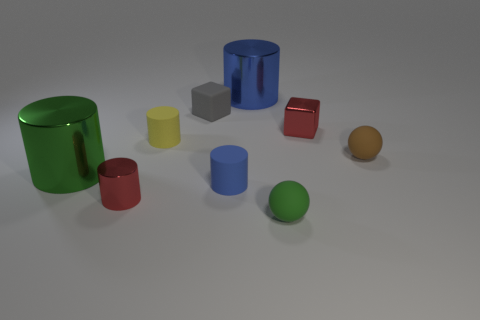Subtract all tiny red metallic cylinders. How many cylinders are left? 4 Subtract all brown balls. How many blue cylinders are left? 2 Subtract all yellow cylinders. How many cylinders are left? 4 Subtract all blocks. How many objects are left? 7 Subtract all blue cylinders. Subtract all gray blocks. How many cylinders are left? 3 Add 1 shiny cylinders. How many shiny cylinders exist? 4 Subtract 0 cyan balls. How many objects are left? 9 Subtract all small shiny cubes. Subtract all metal objects. How many objects are left? 4 Add 7 green balls. How many green balls are left? 8 